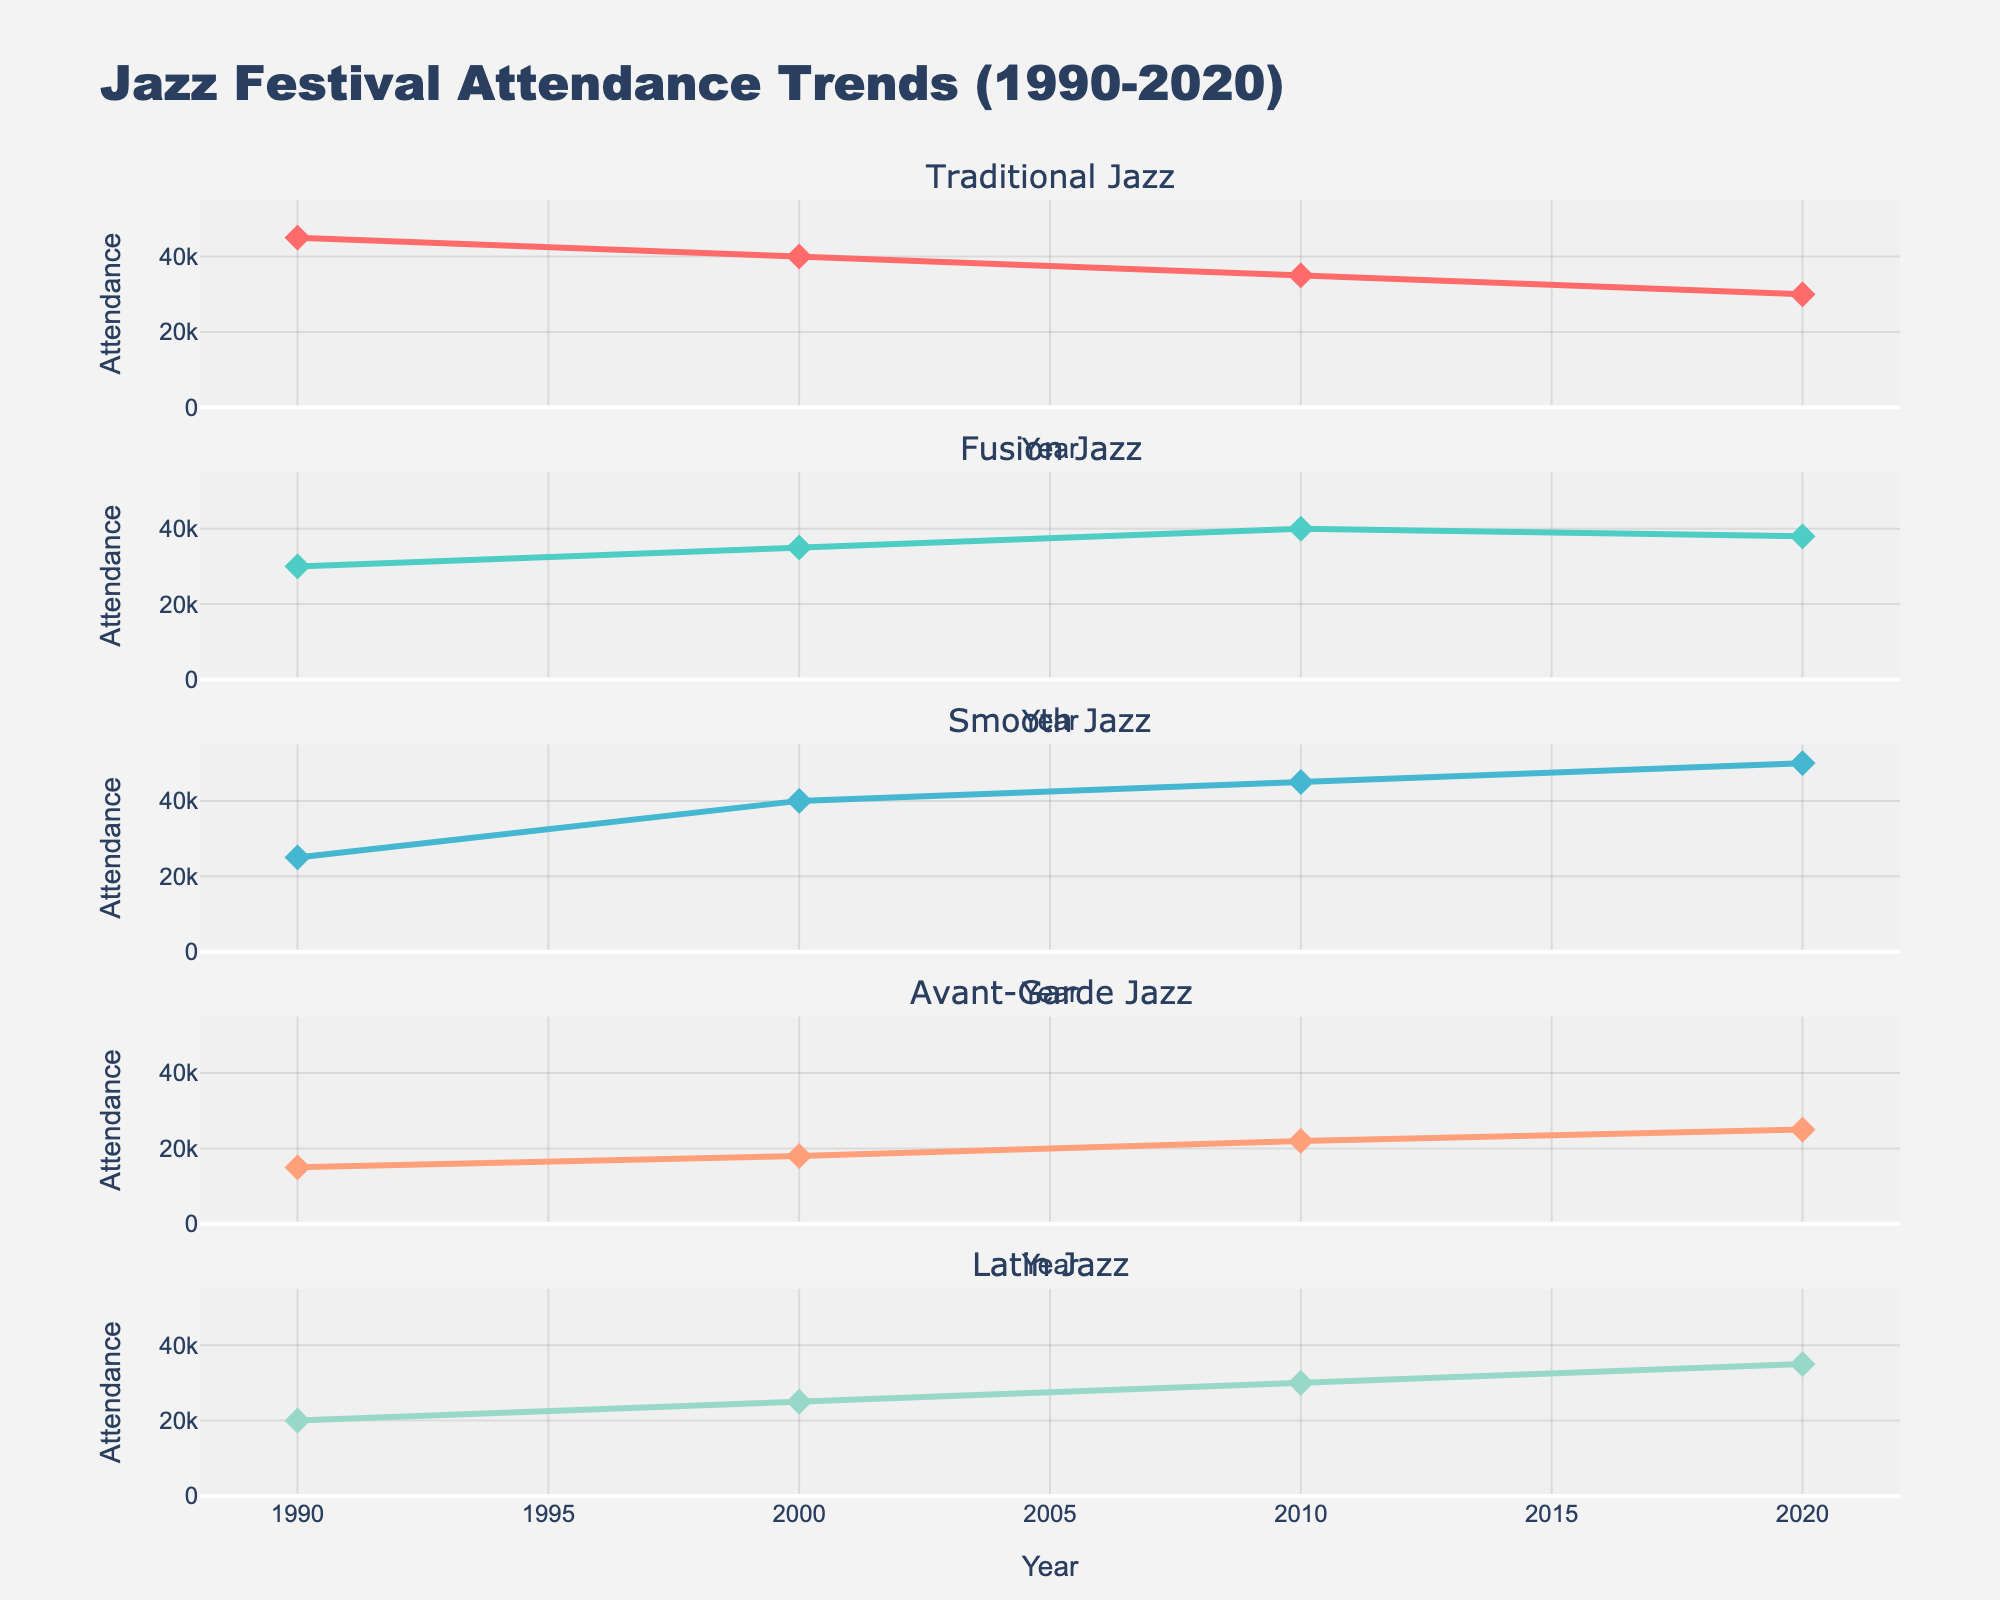what is the trend in Traditional Jazz attendance over the years? The Traditional Jazz attendance shows a declining trend from 45,000 in 1990 to 30,000 in 2020.
Answer: declining What is the highest attendance observed for Smooth Jazz? The highest attendance observed for Smooth Jazz is 50,000 in 2020.
Answer: 50,000 Which year shows the highest attendance for Latin Jazz? The year with the highest attendance for Latin Jazz is 2020 with 35,000 attendees.
Answer: 2020 How does the attendance for Fusion Jazz in 2010 compare to the attendance for Avant-Garde Jazz in the same year? In 2010, the attendance for Fusion Jazz is 40,000, while for Avant-Garde Jazz it is 22,000. Fusion Jazz has more attendees than Avant-Garde Jazz in 2010.
Answer: Fusion Jazz has more attendees What is the difference between the attendances of Traditional Jazz and Smooth Jazz in the year 2000? In 2000, the attendance for Traditional Jazz is 40,000 and Smooth Jazz is 40,000. The difference is 40,000 - 40,000 = 0.
Answer: 0 Which subgenre shows a consistently increasing trend over the years? Smooth Jazz shows a consistently increasing trend from 25,000 in 1990 to 50,000 in 2020.
Answer: Smooth Jazz Between 1990 and 2020, which subgenre had the lowest minimum attendance and what was the value? Avant-Garde Jazz had the lowest minimum attendance of 15,000 in 1990.
Answer: Avant-Garde Jazz with 15,000 What is the average attendance of Latin Jazz over all the years shown? The attendance values for Latin Jazz over the years are 20,000, 25,000, 30,000, and 35,000. Adding them yields 110,000. The average is 110,000 / 4 = 27,500.
Answer: 27,500 How has the attendance for Avant-Garde Jazz changed from 2000 to 2020? The attendance for Avant-Garde Jazz increased from 18,000 in 2000 to 25,000 in 2020.
Answer: increased Which two subgenres have the closest attendance values in the year 2010, and what are their values? In 2010, Traditional Jazz has 35,000 and Fusion Jazz has 40,000. Traditional Jazz and Fusion Jazz have the closest attendance values with a difference of 5,000.
Answer: Traditional Jazz (35,000), Fusion Jazz (40,000) 